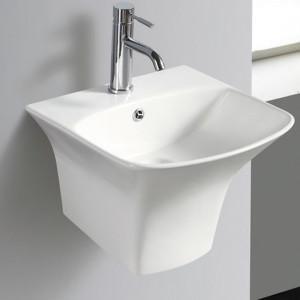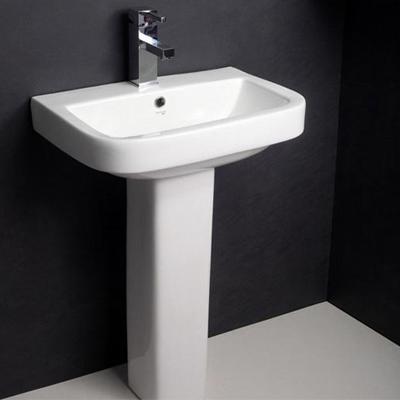The first image is the image on the left, the second image is the image on the right. For the images shown, is this caption "The sink on the right has a rectangular shape." true? Answer yes or no. Yes. 